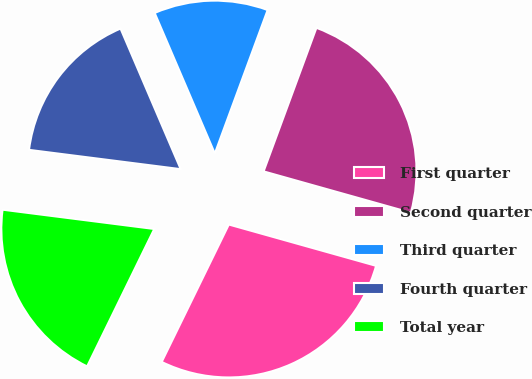Convert chart to OTSL. <chart><loc_0><loc_0><loc_500><loc_500><pie_chart><fcel>First quarter<fcel>Second quarter<fcel>Third quarter<fcel>Fourth quarter<fcel>Total year<nl><fcel>27.88%<fcel>23.74%<fcel>12.05%<fcel>16.55%<fcel>19.78%<nl></chart> 